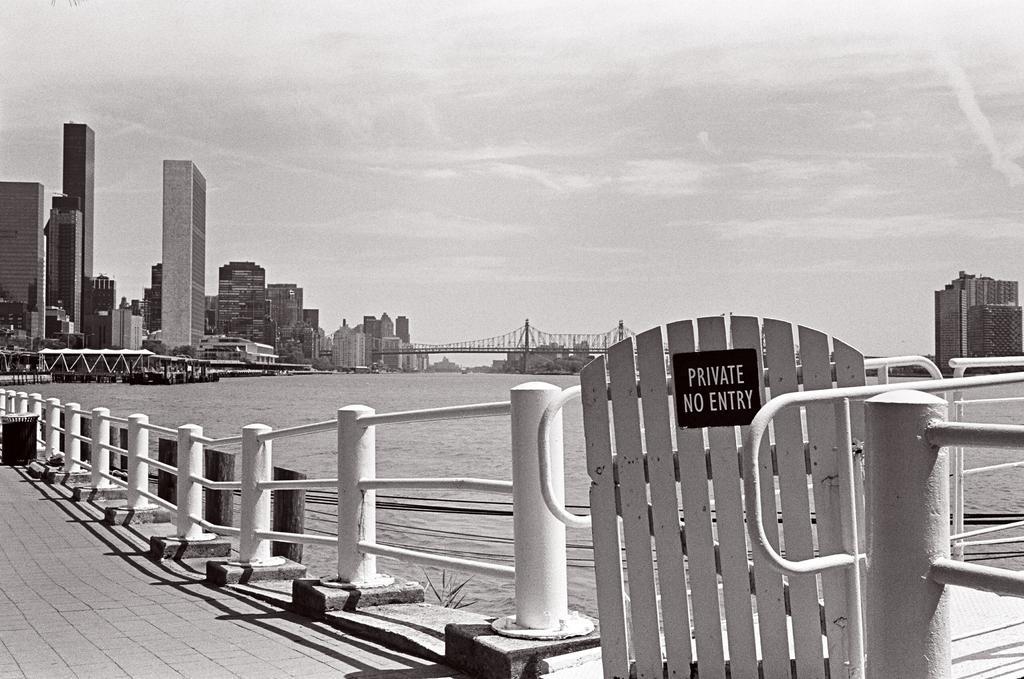Can you describe this image briefly? In this image we can see a road with railing. Also we can see a gate. On the gate there is a board with some text. Near to that there is water. In the back there are buildings. And there is sky with clouds. 